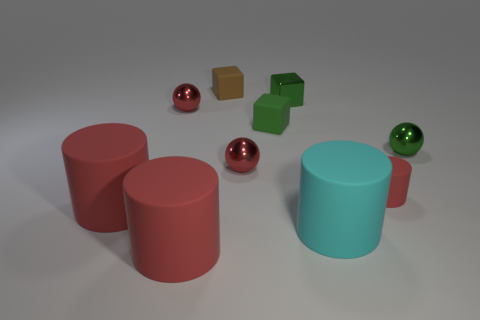Subtract all green spheres. How many red cylinders are left? 3 Subtract all cylinders. How many objects are left? 6 Subtract 2 red cylinders. How many objects are left? 8 Subtract all matte cylinders. Subtract all cubes. How many objects are left? 3 Add 4 big red matte cylinders. How many big red matte cylinders are left? 6 Add 8 big purple rubber objects. How many big purple rubber objects exist? 8 